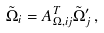Convert formula to latex. <formula><loc_0><loc_0><loc_500><loc_500>\tilde { \Omega } _ { i } = A ^ { T } _ { \Omega , i j } \tilde { \Omega } _ { j } ^ { \prime } \, ,</formula> 